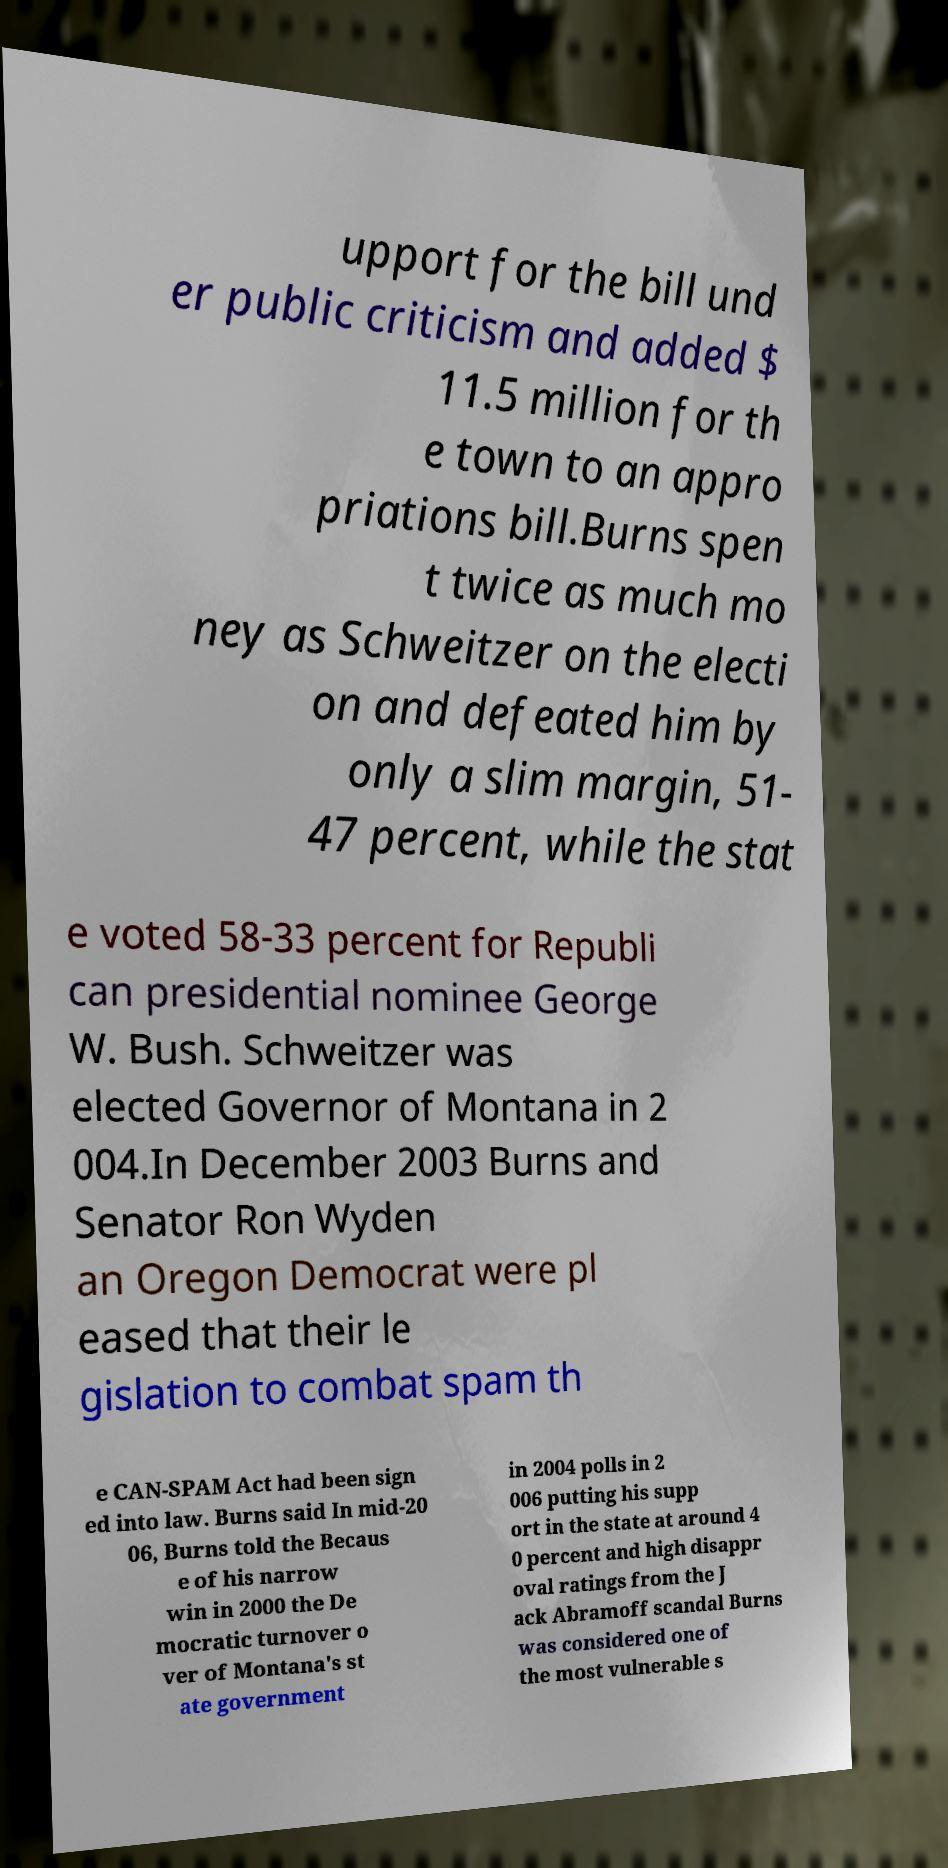I need the written content from this picture converted into text. Can you do that? upport for the bill und er public criticism and added $ 11.5 million for th e town to an appro priations bill.Burns spen t twice as much mo ney as Schweitzer on the electi on and defeated him by only a slim margin, 51- 47 percent, while the stat e voted 58-33 percent for Republi can presidential nominee George W. Bush. Schweitzer was elected Governor of Montana in 2 004.In December 2003 Burns and Senator Ron Wyden an Oregon Democrat were pl eased that their le gislation to combat spam th e CAN-SPAM Act had been sign ed into law. Burns said In mid-20 06, Burns told the Becaus e of his narrow win in 2000 the De mocratic turnover o ver of Montana's st ate government in 2004 polls in 2 006 putting his supp ort in the state at around 4 0 percent and high disappr oval ratings from the J ack Abramoff scandal Burns was considered one of the most vulnerable s 